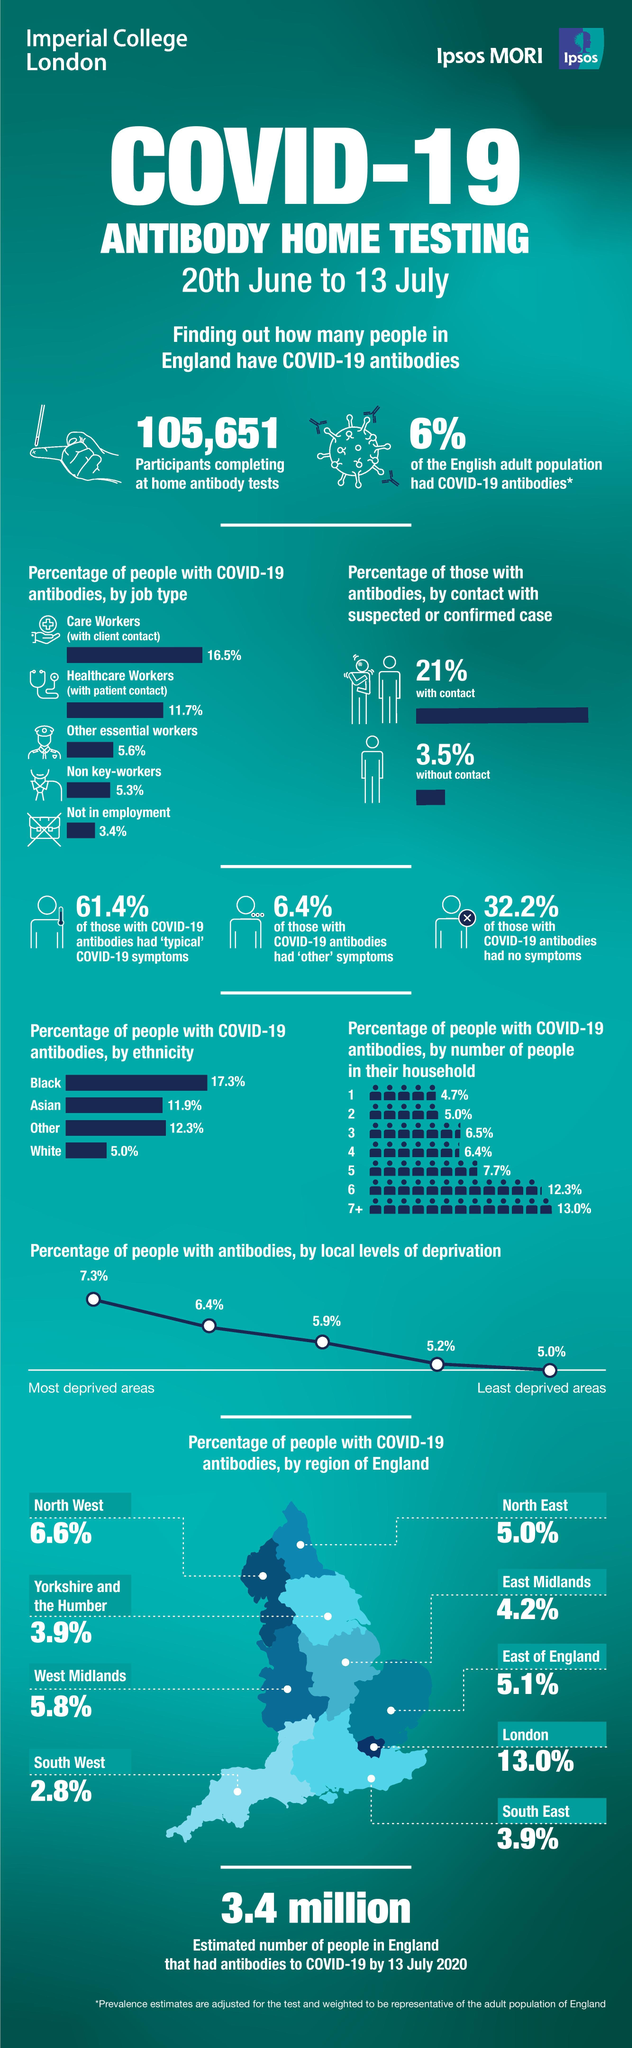Specify some key components in this picture. East Midlands has the third lowest percentage of people with COVID-19 antibodies in England, according to recent data. According to the provided data, contact was the cause of 21% of all cases. According to the data, a significant percentage of non-key workers and care workers, 21.8%, have antibodies against COVID-19. According to the data provided, the percentage of people in Yorkshire and the Humber region of England who have antibodies against COVID-19 is the same as the percentage of people in the South East region of England. The study found that there was a significant difference in the prevalence of antibodies in people living in the most deprived areas compared to those living in the least deprived areas, with a difference of 2.3%. 